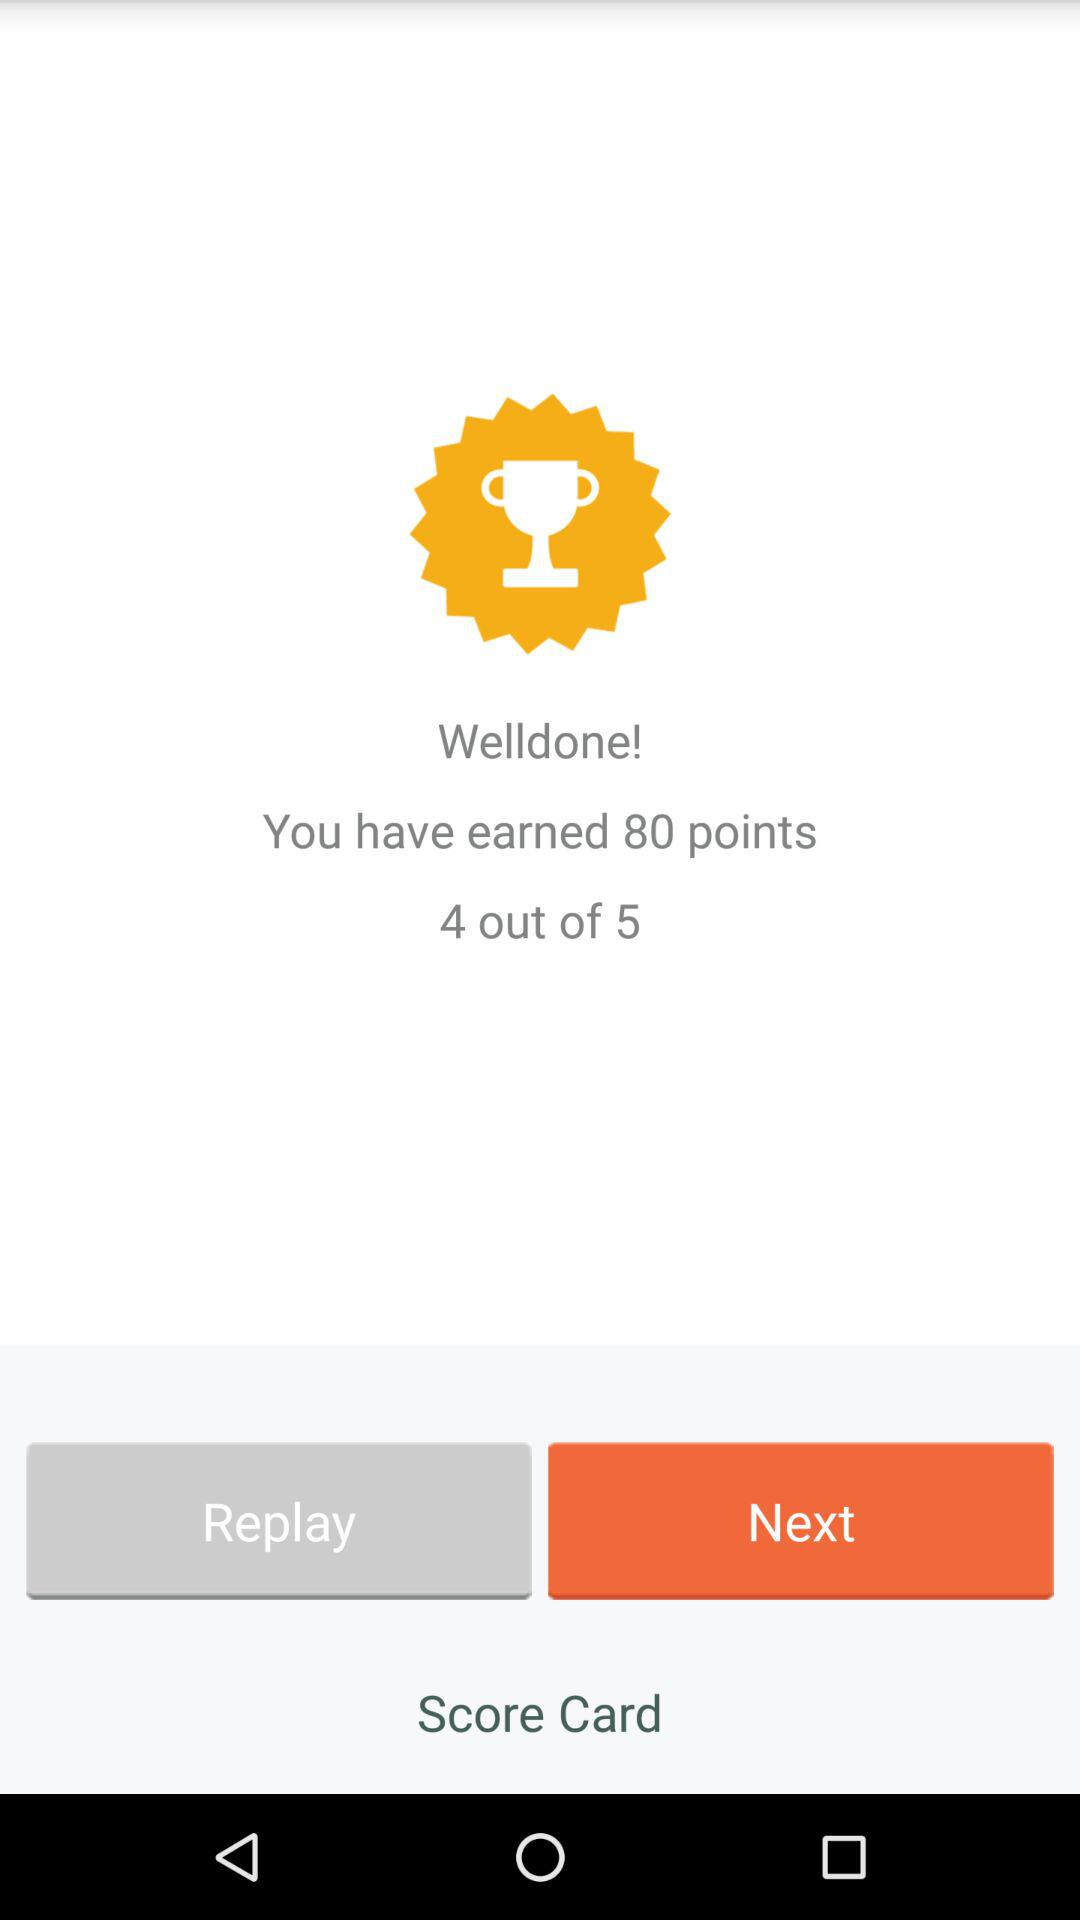How many points are earned? There are 80 points earned. 